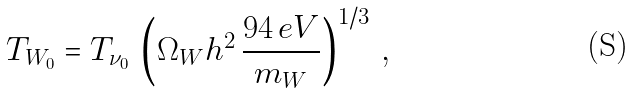<formula> <loc_0><loc_0><loc_500><loc_500>T _ { W _ { 0 } } = T _ { \nu _ { 0 } } \, \left ( \Omega _ { W } h ^ { 2 } \, \frac { 9 4 \, e V } { m _ { W } } \right ) ^ { 1 / 3 } \, ,</formula> 